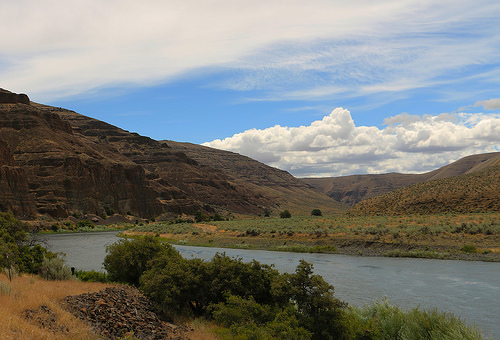<image>
Is there a clouds behind the water? Yes. From this viewpoint, the clouds is positioned behind the water, with the water partially or fully occluding the clouds. Is the hills behind the water? Yes. From this viewpoint, the hills is positioned behind the water, with the water partially or fully occluding the hills. 